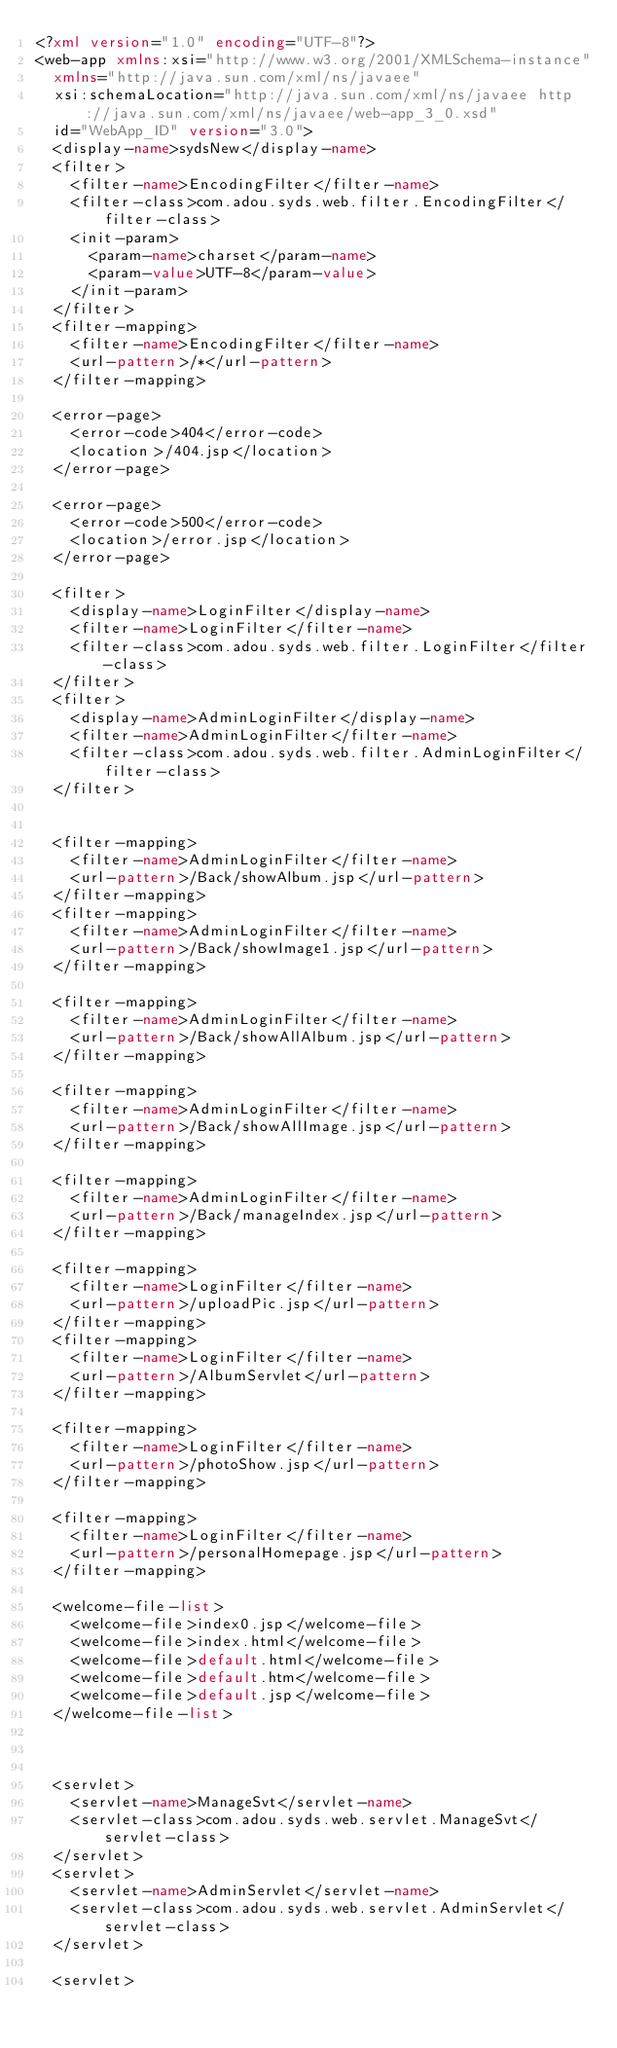<code> <loc_0><loc_0><loc_500><loc_500><_XML_><?xml version="1.0" encoding="UTF-8"?>
<web-app xmlns:xsi="http://www.w3.org/2001/XMLSchema-instance"
	xmlns="http://java.sun.com/xml/ns/javaee"
	xsi:schemaLocation="http://java.sun.com/xml/ns/javaee http://java.sun.com/xml/ns/javaee/web-app_3_0.xsd"
	id="WebApp_ID" version="3.0">
	<display-name>sydsNew</display-name>
	<filter>
		<filter-name>EncodingFilter</filter-name>
		<filter-class>com.adou.syds.web.filter.EncodingFilter</filter-class>
		<init-param>
			<param-name>charset</param-name>
			<param-value>UTF-8</param-value>
		</init-param>
	</filter>
	<filter-mapping>
		<filter-name>EncodingFilter</filter-name>
		<url-pattern>/*</url-pattern>
	</filter-mapping>

	<error-page>
		<error-code>404</error-code>
		<location>/404.jsp</location>
	</error-page>

	<error-page>
		<error-code>500</error-code>
		<location>/error.jsp</location>
	</error-page>

	<filter>
		<display-name>LoginFilter</display-name>
		<filter-name>LoginFilter</filter-name>
		<filter-class>com.adou.syds.web.filter.LoginFilter</filter-class>
	</filter>
	<filter>
		<display-name>AdminLoginFilter</display-name>
		<filter-name>AdminLoginFilter</filter-name>
		<filter-class>com.adou.syds.web.filter.AdminLoginFilter</filter-class>
	</filter>


	<filter-mapping>
		<filter-name>AdminLoginFilter</filter-name>
		<url-pattern>/Back/showAlbum.jsp</url-pattern>
	</filter-mapping>
	<filter-mapping>
		<filter-name>AdminLoginFilter</filter-name>
		<url-pattern>/Back/showImage1.jsp</url-pattern>
	</filter-mapping>
	
	<filter-mapping>
		<filter-name>AdminLoginFilter</filter-name>
		<url-pattern>/Back/showAllAlbum.jsp</url-pattern>
	</filter-mapping>
	
	<filter-mapping>
		<filter-name>AdminLoginFilter</filter-name>
		<url-pattern>/Back/showAllImage.jsp</url-pattern>
	</filter-mapping>
	
	<filter-mapping>
		<filter-name>AdminLoginFilter</filter-name>
		<url-pattern>/Back/manageIndex.jsp</url-pattern>
	</filter-mapping>
	
	<filter-mapping>
		<filter-name>LoginFilter</filter-name>
		<url-pattern>/uploadPic.jsp</url-pattern>
	</filter-mapping>
	<filter-mapping>
		<filter-name>LoginFilter</filter-name>
		<url-pattern>/AlbumServlet</url-pattern>
	</filter-mapping>

	<filter-mapping>
		<filter-name>LoginFilter</filter-name>
		<url-pattern>/photoShow.jsp</url-pattern>
	</filter-mapping>

	<filter-mapping>
		<filter-name>LoginFilter</filter-name>
		<url-pattern>/personalHomepage.jsp</url-pattern>
	</filter-mapping>

	<welcome-file-list>
		<welcome-file>index0.jsp</welcome-file>
		<welcome-file>index.html</welcome-file>
		<welcome-file>default.html</welcome-file>
		<welcome-file>default.htm</welcome-file>
		<welcome-file>default.jsp</welcome-file>
	</welcome-file-list>



  <servlet>
    <servlet-name>ManageSvt</servlet-name>
    <servlet-class>com.adou.syds.web.servlet.ManageSvt</servlet-class>
  </servlet>
	<servlet>
		<servlet-name>AdminServlet</servlet-name>
		<servlet-class>com.adou.syds.web.servlet.AdminServlet</servlet-class>
	</servlet>

	<servlet></code> 